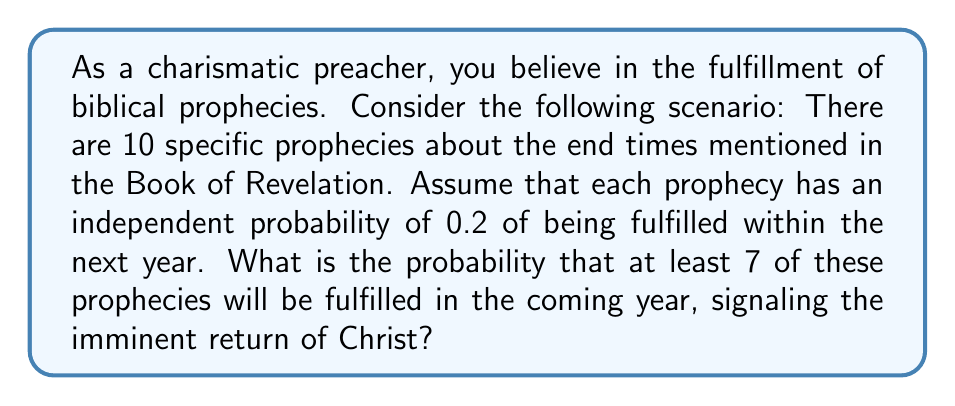What is the answer to this math problem? To solve this problem, we'll use the binomial probability distribution, as we're dealing with independent events with a fixed probability of success.

Let $X$ be the number of prophecies fulfilled.
$n = 10$ (total number of prophecies)
$p = 0.2$ (probability of each prophecy being fulfilled)
$q = 1 - p = 0.8$ (probability of each prophecy not being fulfilled)

We want to find $P(X \geq 7)$, which is equivalent to:
$P(X \geq 7) = P(X = 7) + P(X = 8) + P(X = 9) + P(X = 10)$

Using the binomial probability formula:
$$P(X = k) = \binom{n}{k} p^k q^{n-k}$$

For each value of $k$ from 7 to 10:

$P(X = 7) = \binom{10}{7} (0.2)^7 (0.8)^3 = 120 \cdot 0.0000128 \cdot 0.512 = 0.000786432$

$P(X = 8) = \binom{10}{8} (0.2)^8 (0.8)^2 = 45 \cdot 0.00000256 \cdot 0.64 = 0.00007372$

$P(X = 9) = \binom{10}{9} (0.2)^9 (0.8)^1 = 10 \cdot 0.000000512 \cdot 0.8 = 0.000004096$

$P(X = 10) = \binom{10}{10} (0.2)^{10} (0.8)^0 = 1 \cdot 0.0000001024 \cdot 1 = 0.0000001024$

Sum these probabilities:
$P(X \geq 7) = 0.000786432 + 0.00007372 + 0.000004096 + 0.0000001024 = 0.0008643504$
Answer: The probability that at least 7 out of 10 biblical prophecies will be fulfilled in the coming year is approximately 0.000864 or 0.0864%. 